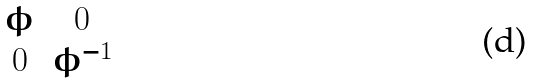<formula> <loc_0><loc_0><loc_500><loc_500>\begin{matrix} \phi & 0 \\ 0 & \phi ^ { - 1 } \end{matrix}</formula> 